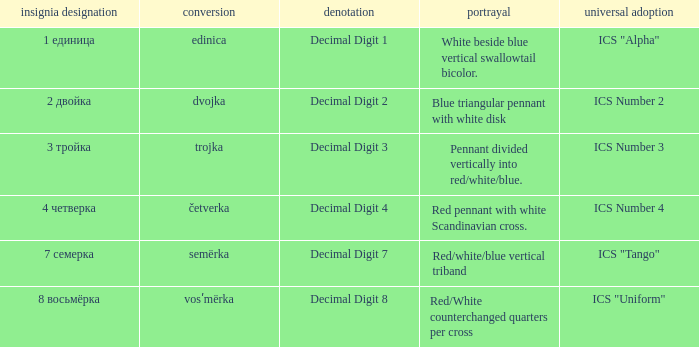How many different descriptions are there for the flag that means decimal digit 2? 1.0. 